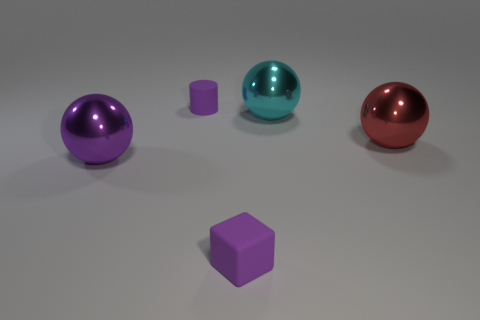Add 3 blue rubber cubes. How many objects exist? 8 Subtract all cylinders. How many objects are left? 4 Subtract 1 purple cubes. How many objects are left? 4 Subtract all matte cubes. Subtract all purple matte objects. How many objects are left? 2 Add 3 large cyan metallic spheres. How many large cyan metallic spheres are left? 4 Add 2 small rubber objects. How many small rubber objects exist? 4 